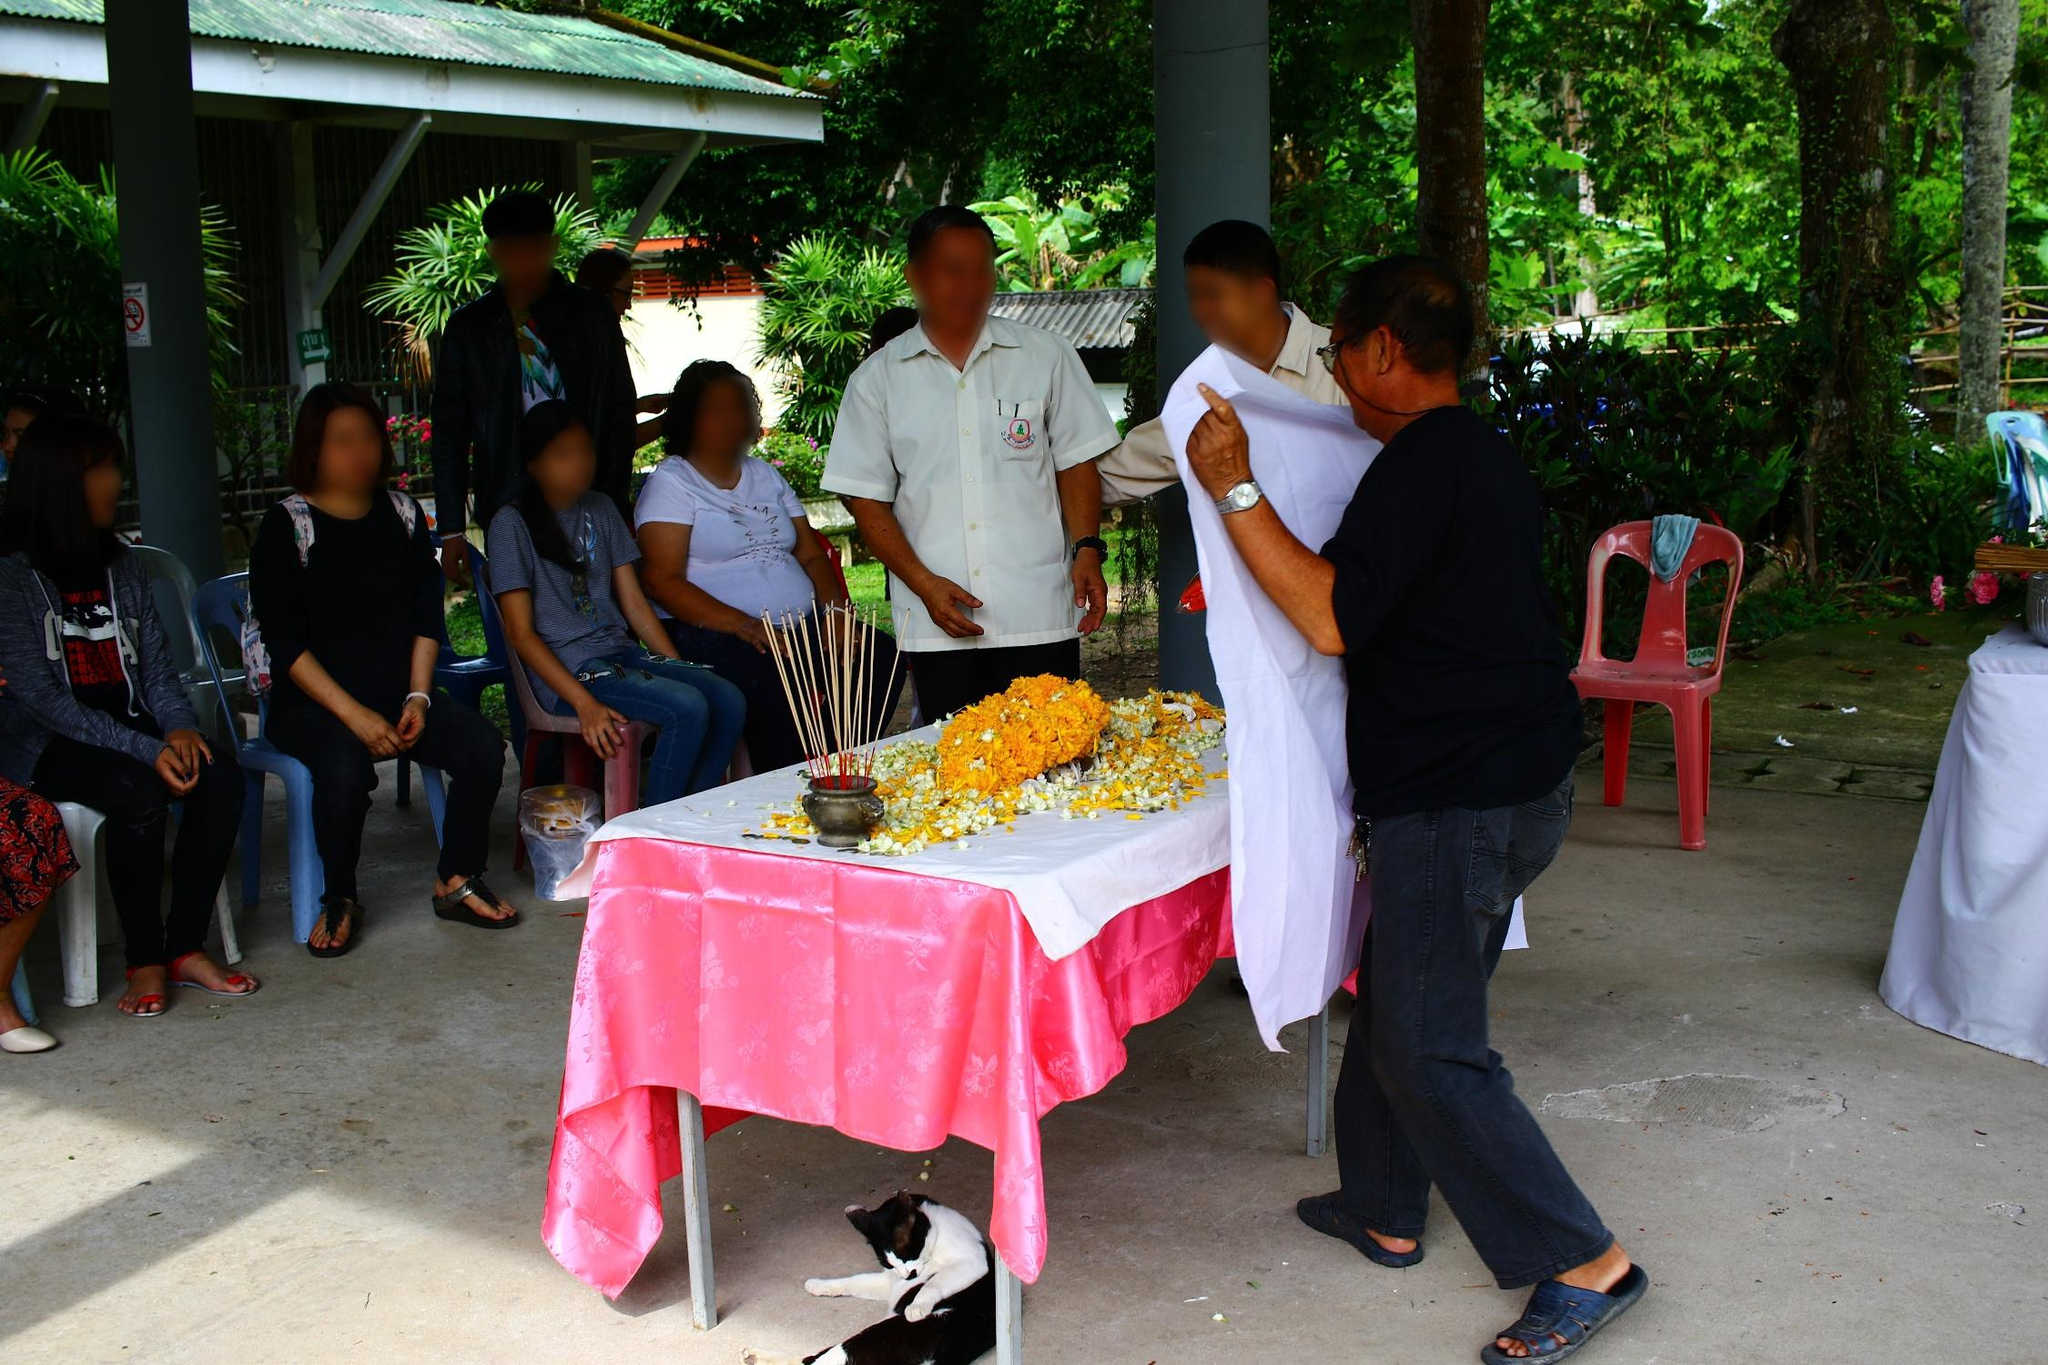Analyze the image in a comprehensive and detailed manner. The image depicts a serene yet vibrant gathering, possibly a cultural or religious event, under an open shelter surrounded by lush greenery. A central table is covered with a pink tablecloth and decorated elaborately with an arrangement of marigold flowers and incense sticks, indicative of a ceremonial purpose. Surrounding this table, various individuals—mostly adults—are engaged in what appears to be a ritual, dressed casually, suggesting a communal, informal occasion. Notably, a black and white cat lounges near the table, adding a relaxed and homely feel to the scene. The image is a colorful and intimate portrayal of traditional communal life, capturing a moment of shared ritual and social interaction in a tropical environment. 